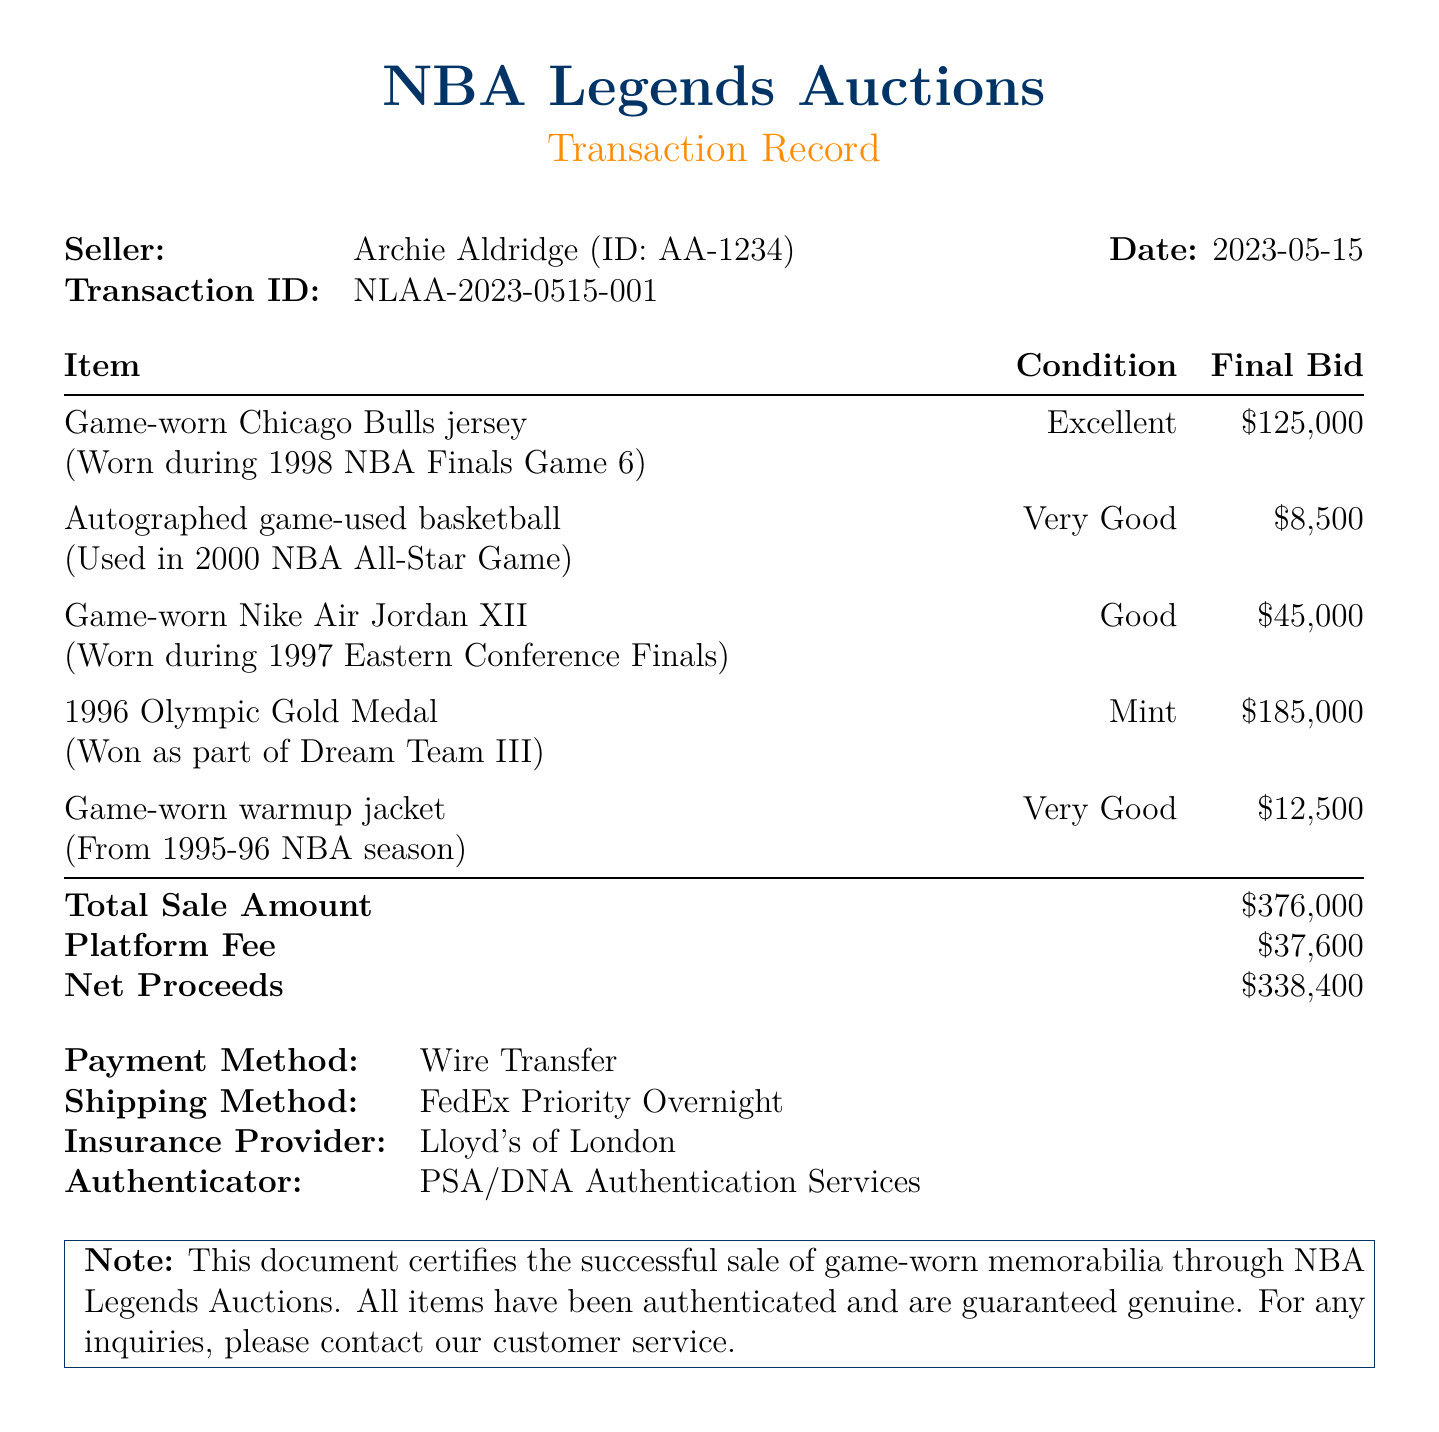What is the seller's name? The seller is named Archie Aldridge, as stated in the document.
Answer: Archie Aldridge What is the final bid amount for the Game-worn Chicago Bulls jersey? The final bid amount is specifically listed for the Game-worn Chicago Bulls jersey in the document.
Answer: $125,000 How many items were sold in the transaction? The document lists five items sold, indicated by the itemsSold section.
Answer: 5 What is the total sale amount? The total sale amount is summarized at the end of the transaction record in the document.
Answer: $376,000 Who is the buyer of the game-worn warmup jacket? The buyer's name for the game-worn warmup jacket is provided in the document.
Answer: Chicago Sports Museum What was the condition of the 1996 Olympic Gold Medal? The condition of the 1996 Olympic Gold Medal is specified in the document.
Answer: Mint What percentage of the total sale amount is the platform fee? The platform fee is $37,600, which is 10% of the total sale amount of $376,000, as calculated from the document's details.
Answer: 10% What payment method was used for the transaction? The payment method for this transaction is outlined in the document.
Answer: Wire Transfer What insurance provider is mentioned in the document? The document includes the name of the insurance provider for this transaction.
Answer: Lloyd's of London Which item was worn during the 1998 NBA Finals? The document specifies which item was worn during the 1998 NBA Finals.
Answer: Game-worn Chicago Bulls jersey 